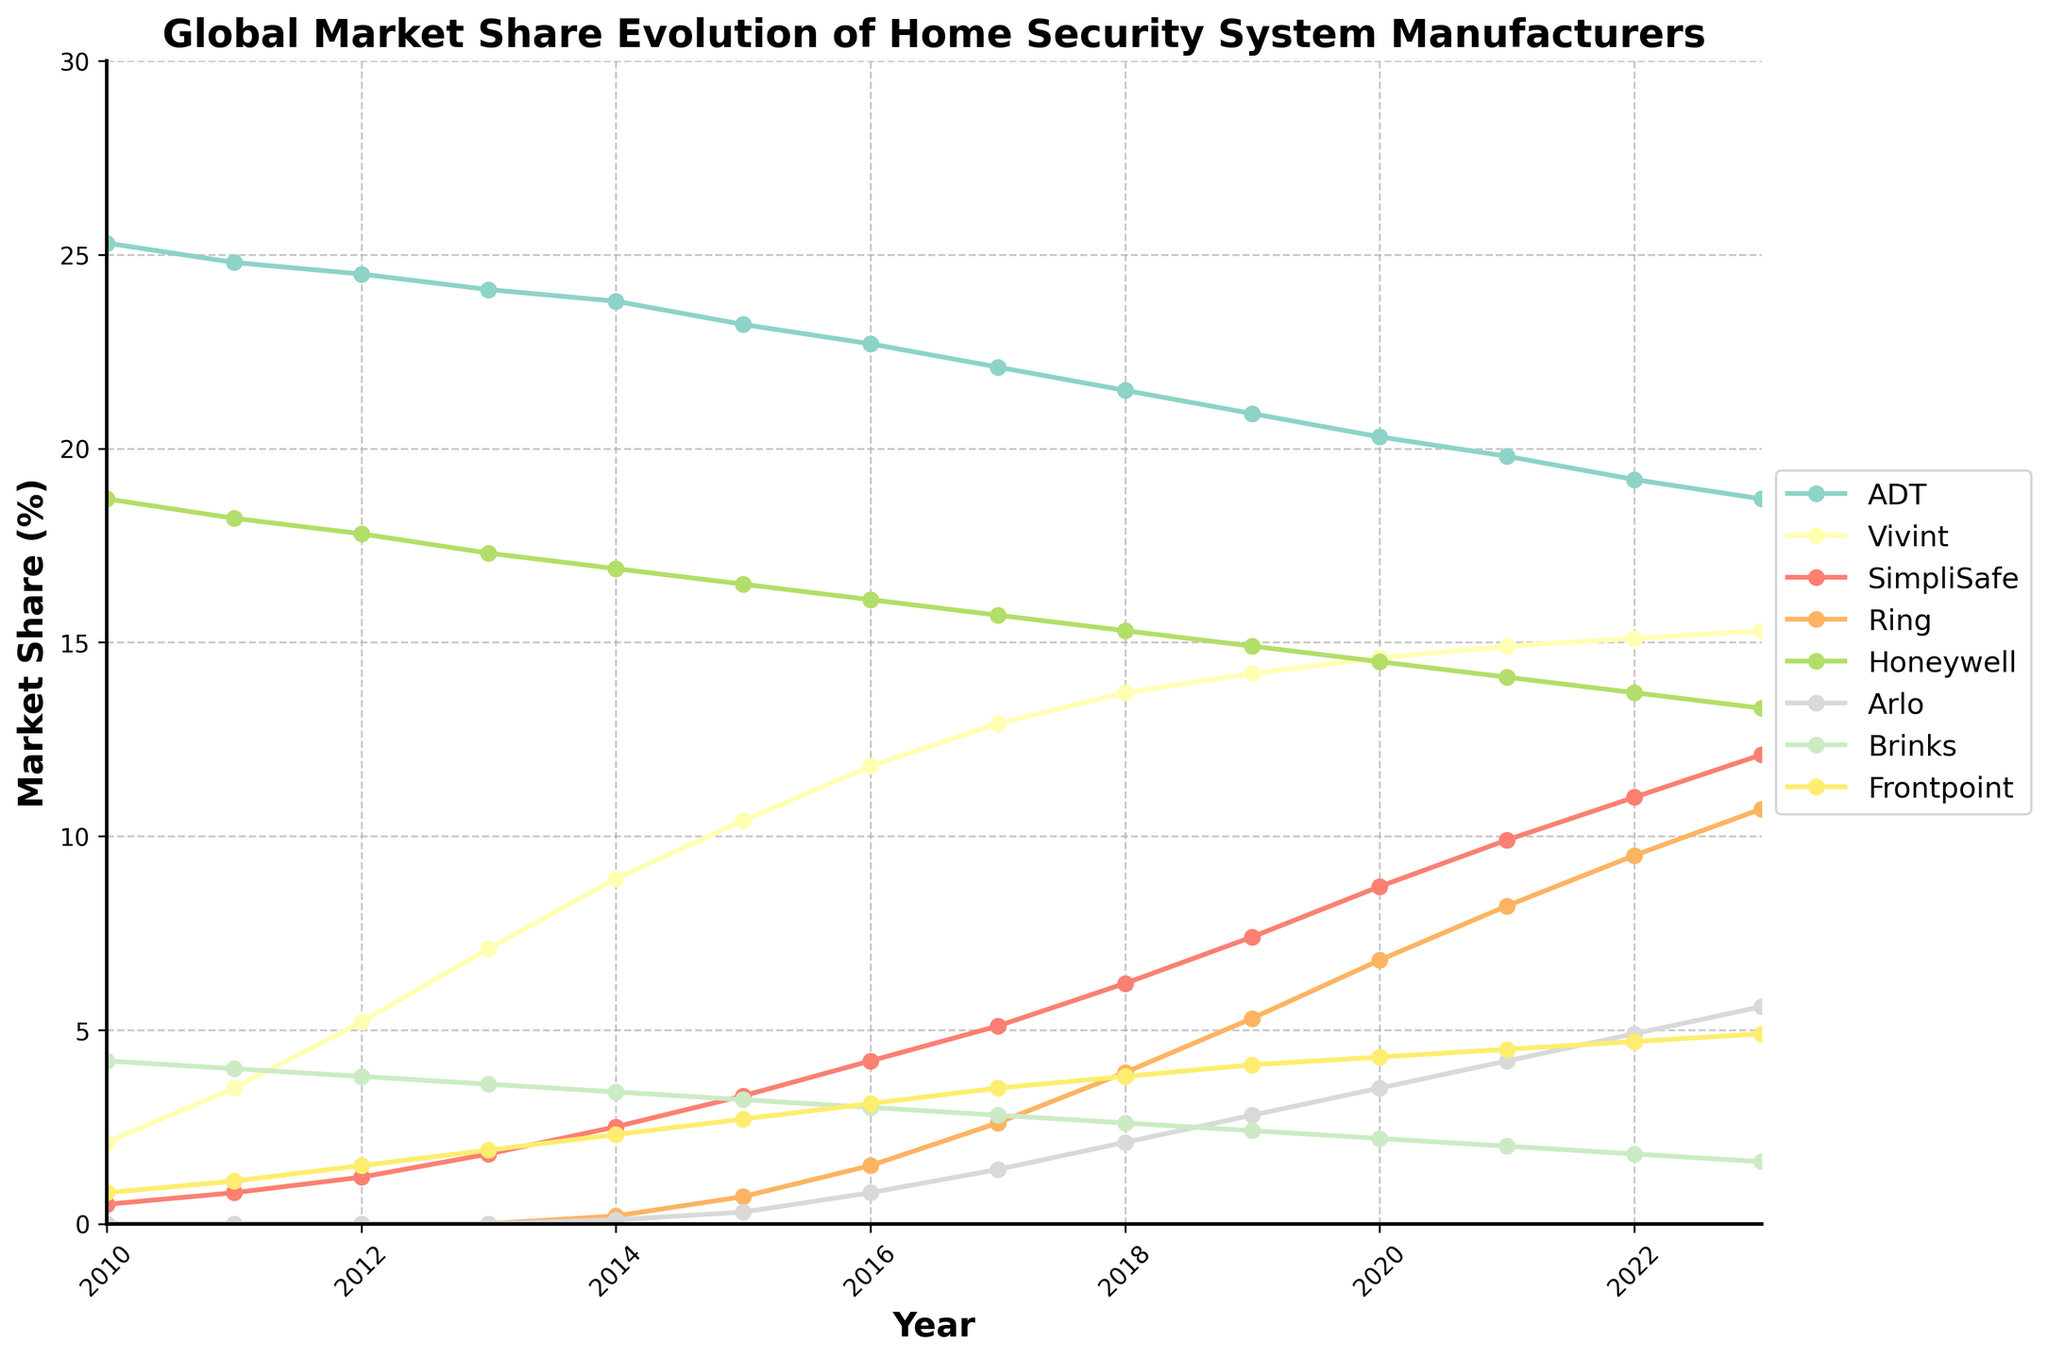What is the trend in ADT's market share from 2010 to 2023? ADT’s market share starts at 25.3 in 2010 and steadily declines to 18.7 by 2023. By observing the line for ADT, it continuously decreases over the years.
Answer: It declines Which company had the highest market share in 2023? By looking at the end points of each line for 2023, ADT had the highest market share with 18.7%.
Answer: ADT How has SimpliSafe's market share changed from 2010 to 2023? The market share of SimpliSafe has increased each year. It started at 0.5 in 2010 and rose sharply to 12.1 by 2023.
Answer: It increased Which year did Ring first appear in the market, and what was its market share at that time? Ring first appears on the chart in 2014 with a market share of 0.2.
Answer: 2014, 0.2 Compare the market share growth rate of Vivint and SimpliSafe from 2010 to 2023. Which company grew faster? In 2010, Vivint had 2.1, and it increased to 15.3 by 2023 (increase of 13.2). SimpliSafe had 0.5 in 2010, increased to 12.1 by 2023 (increase of 11.6). To find out the growth rate, calculate the differences: Vivint = 13.2 and SimpliSafe = 11.6. Vivint grew faster.
Answer: Vivint Which companies had a market share of less than 5% in 2010, and how did their market shares evolve by 2023? In 2010, Vivint (2.1), SimpliSafe (0.5), Arlo (0), Brinks (4.2), Frontpoint (0.8) had less than 5%. By 2023, Vivint increased to 15.3, SimpliSafe to 12.1, Arlo to 5.6, Brinks decreased to 1.6, Frontpoint increased to 4.9.
Answer: Vivint, SimpliSafe, Arlo, Brinks, Frontpoint In which year did Honeywell's market share first drop below 15%? Observe the trend of the Honeywell line. In 2023, Honeywell's market share is 13.3%. It is above 15% in every previous year. Thus, 2023 is the first year it dropped below 15%.
Answer: 2023 Compare the market share of Ring and Arlo in 2020. Which was higher, and by how much? In 2020, Ring had a market share of 6.8, and Arlo had 3.5. The difference is calculated by 6.8 - 3.5 = 3.3. Thus, Ring had a higher market share by 3.3%.
Answer: Ring by 3.3 What is the average market share of Brinks from 2010 to 2023? Sum all the market shares of Brinks from 2010 to 2023 (4.2 + 4.0 + 3.8 + 3.6 + 3.4 + 3.2 + 3.0 + 2.8 + 2.6 + 2.4 + 2.2 + 2.0 + 1.8 + 1.6) = 44.6. The number of years is 14. The average is 44.6 / 14 ≈ 3.19.
Answer: 3.19 What is the combined market share of Frontpoint and Arlo in 2023? Frontpoint's share in 2023 is 4.9, and Arlo's is 5.6. Adding them together gives 4.9 + 5.6 = 10.5.
Answer: 10.5 